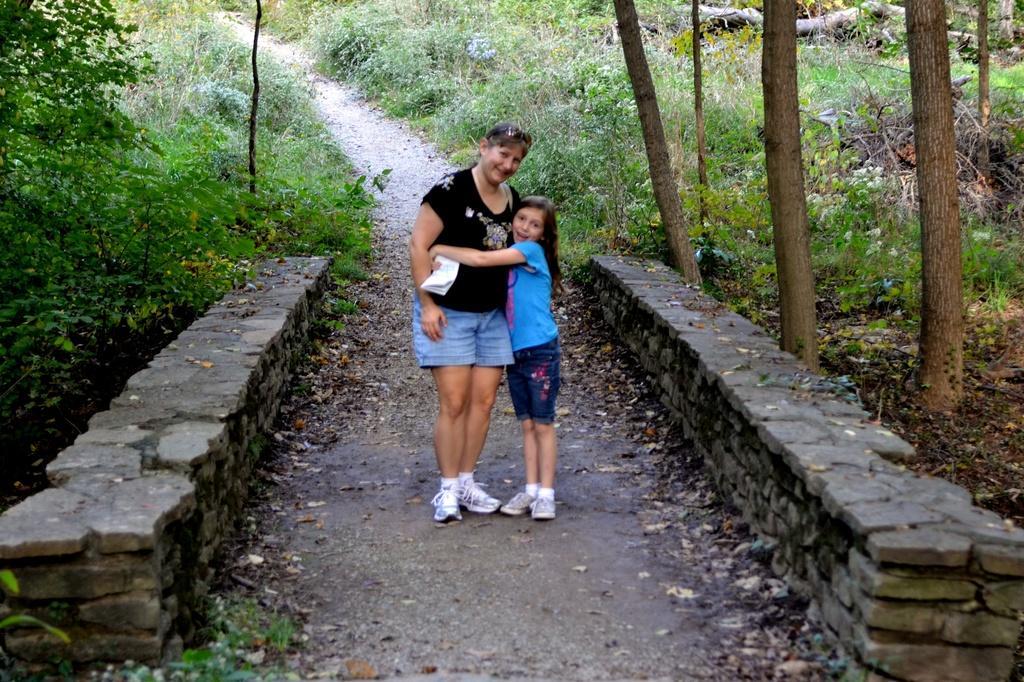How would you summarize this image in a sentence or two? In this image, there are a few people. We can see the ground and the stone wall. We can also see some plants, trees and some grass. 